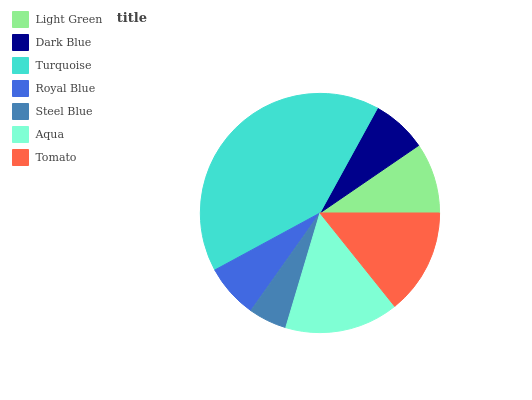Is Steel Blue the minimum?
Answer yes or no. Yes. Is Turquoise the maximum?
Answer yes or no. Yes. Is Dark Blue the minimum?
Answer yes or no. No. Is Dark Blue the maximum?
Answer yes or no. No. Is Light Green greater than Dark Blue?
Answer yes or no. Yes. Is Dark Blue less than Light Green?
Answer yes or no. Yes. Is Dark Blue greater than Light Green?
Answer yes or no. No. Is Light Green less than Dark Blue?
Answer yes or no. No. Is Light Green the high median?
Answer yes or no. Yes. Is Light Green the low median?
Answer yes or no. Yes. Is Aqua the high median?
Answer yes or no. No. Is Steel Blue the low median?
Answer yes or no. No. 